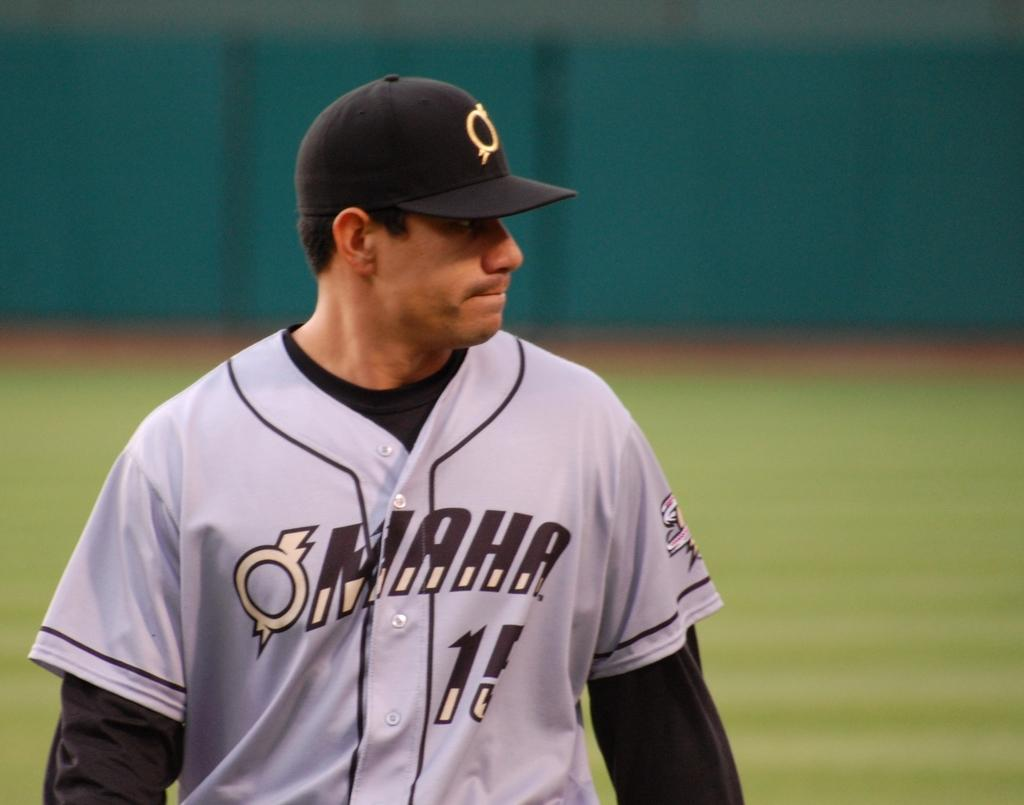<image>
Describe the image concisely. An Omaha baseball player wears jersey number 11. 